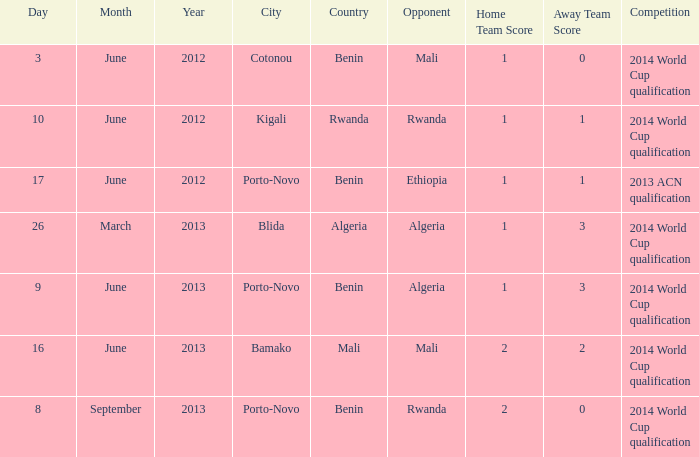What is the score from the game where Algeria is the opponent at Porto-Novo? 1-3. 